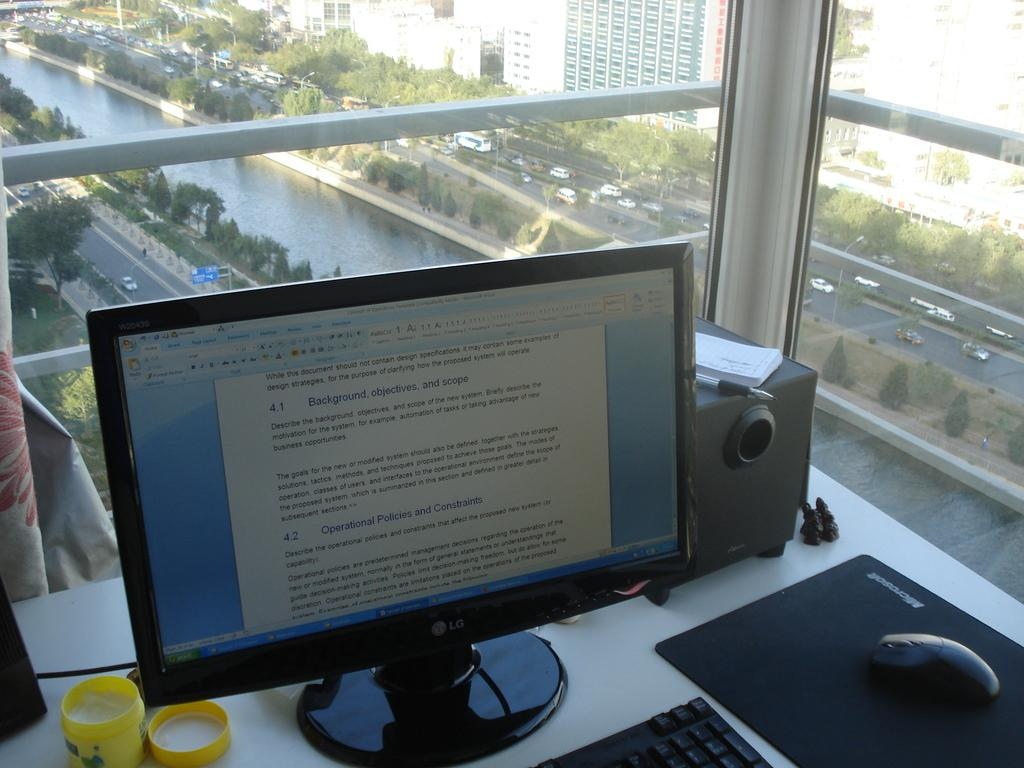<image>
Summarize the visual content of the image. A computer monitor on a desk displaying a word document of Operational Policies and Constriants 